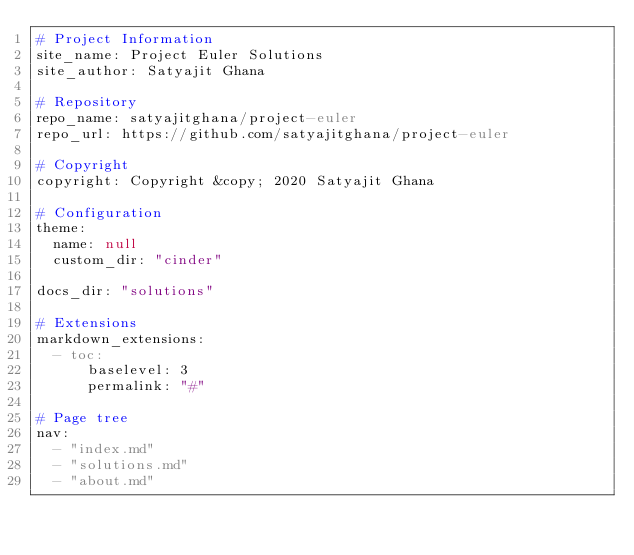<code> <loc_0><loc_0><loc_500><loc_500><_YAML_># Project Information
site_name: Project Euler Solutions
site_author: Satyajit Ghana

# Repository
repo_name: satyajitghana/project-euler
repo_url: https://github.com/satyajitghana/project-euler

# Copyright
copyright: Copyright &copy; 2020 Satyajit Ghana

# Configuration
theme:
  name: null
  custom_dir: "cinder"

docs_dir: "solutions"

# Extensions
markdown_extensions:
  - toc:
      baselevel: 3
      permalink: "#"

# Page tree
nav:
  - "index.md"
  - "solutions.md"
  - "about.md"
</code> 